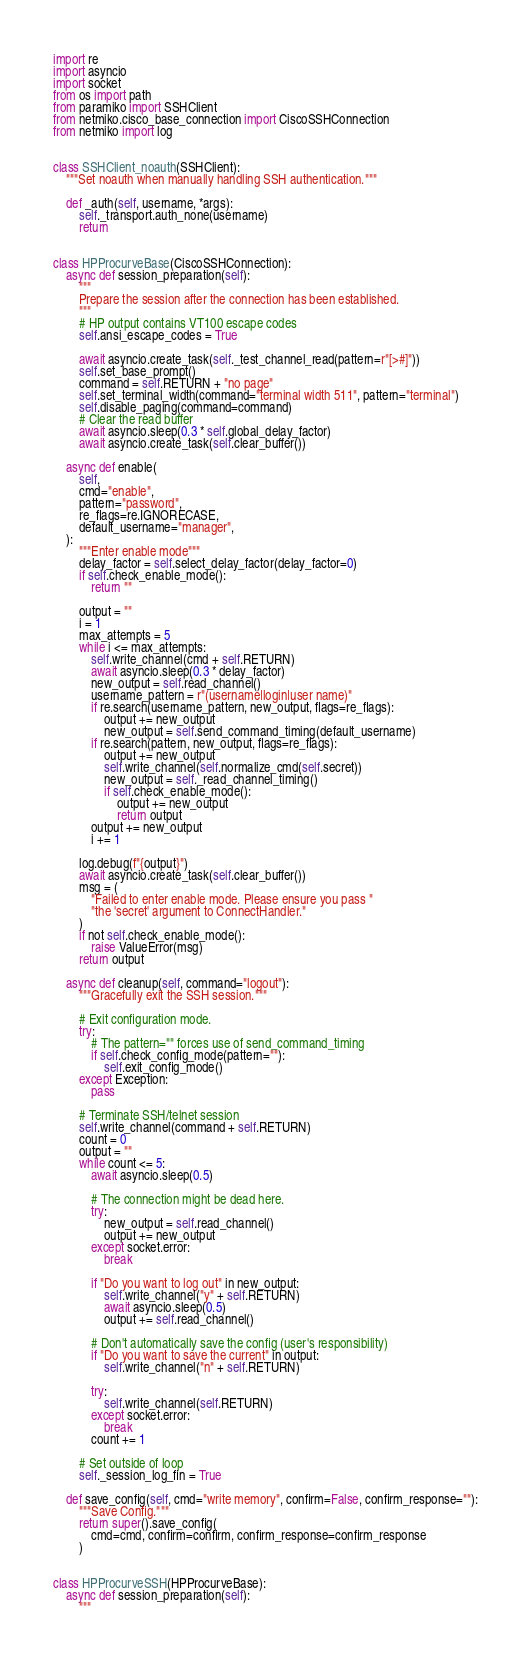Convert code to text. <code><loc_0><loc_0><loc_500><loc_500><_Python_>import re
import asyncio
import socket
from os import path
from paramiko import SSHClient
from netmiko.cisco_base_connection import CiscoSSHConnection
from netmiko import log


class SSHClient_noauth(SSHClient):
    """Set noauth when manually handling SSH authentication."""

    def _auth(self, username, *args):
        self._transport.auth_none(username)
        return


class HPProcurveBase(CiscoSSHConnection):
    async def session_preparation(self):
        """
        Prepare the session after the connection has been established.
        """
        # HP output contains VT100 escape codes
        self.ansi_escape_codes = True

        await asyncio.create_task(self._test_channel_read(pattern=r"[>#]"))
        self.set_base_prompt()
        command = self.RETURN + "no page"
        self.set_terminal_width(command="terminal width 511", pattern="terminal")
        self.disable_paging(command=command)
        # Clear the read buffer
        await asyncio.sleep(0.3 * self.global_delay_factor)
        await asyncio.create_task(self.clear_buffer())

    async def enable(
        self,
        cmd="enable",
        pattern="password",
        re_flags=re.IGNORECASE,
        default_username="manager",
    ):
        """Enter enable mode"""
        delay_factor = self.select_delay_factor(delay_factor=0)
        if self.check_enable_mode():
            return ""

        output = ""
        i = 1
        max_attempts = 5
        while i <= max_attempts:
            self.write_channel(cmd + self.RETURN)
            await asyncio.sleep(0.3 * delay_factor)
            new_output = self.read_channel()
            username_pattern = r"(username|login|user name)"
            if re.search(username_pattern, new_output, flags=re_flags):
                output += new_output
                new_output = self.send_command_timing(default_username)
            if re.search(pattern, new_output, flags=re_flags):
                output += new_output
                self.write_channel(self.normalize_cmd(self.secret))
                new_output = self._read_channel_timing()
                if self.check_enable_mode():
                    output += new_output
                    return output
            output += new_output
            i += 1

        log.debug(f"{output}")
        await asyncio.create_task(self.clear_buffer())
        msg = (
            "Failed to enter enable mode. Please ensure you pass "
            "the 'secret' argument to ConnectHandler."
        )
        if not self.check_enable_mode():
            raise ValueError(msg)
        return output

    async def cleanup(self, command="logout"):
        """Gracefully exit the SSH session."""

        # Exit configuration mode.
        try:
            # The pattern="" forces use of send_command_timing
            if self.check_config_mode(pattern=""):
                self.exit_config_mode()
        except Exception:
            pass

        # Terminate SSH/telnet session
        self.write_channel(command + self.RETURN)
        count = 0
        output = ""
        while count <= 5:
            await asyncio.sleep(0.5)

            # The connection might be dead here.
            try:
                new_output = self.read_channel()
                output += new_output
            except socket.error:
                break

            if "Do you want to log out" in new_output:
                self.write_channel("y" + self.RETURN)
                await asyncio.sleep(0.5)
                output += self.read_channel()

            # Don't automatically save the config (user's responsibility)
            if "Do you want to save the current" in output:
                self.write_channel("n" + self.RETURN)

            try:
                self.write_channel(self.RETURN)
            except socket.error:
                break
            count += 1

        # Set outside of loop
        self._session_log_fin = True

    def save_config(self, cmd="write memory", confirm=False, confirm_response=""):
        """Save Config."""
        return super().save_config(
            cmd=cmd, confirm=confirm, confirm_response=confirm_response
        )


class HPProcurveSSH(HPProcurveBase):
    async def session_preparation(self):
        """</code> 